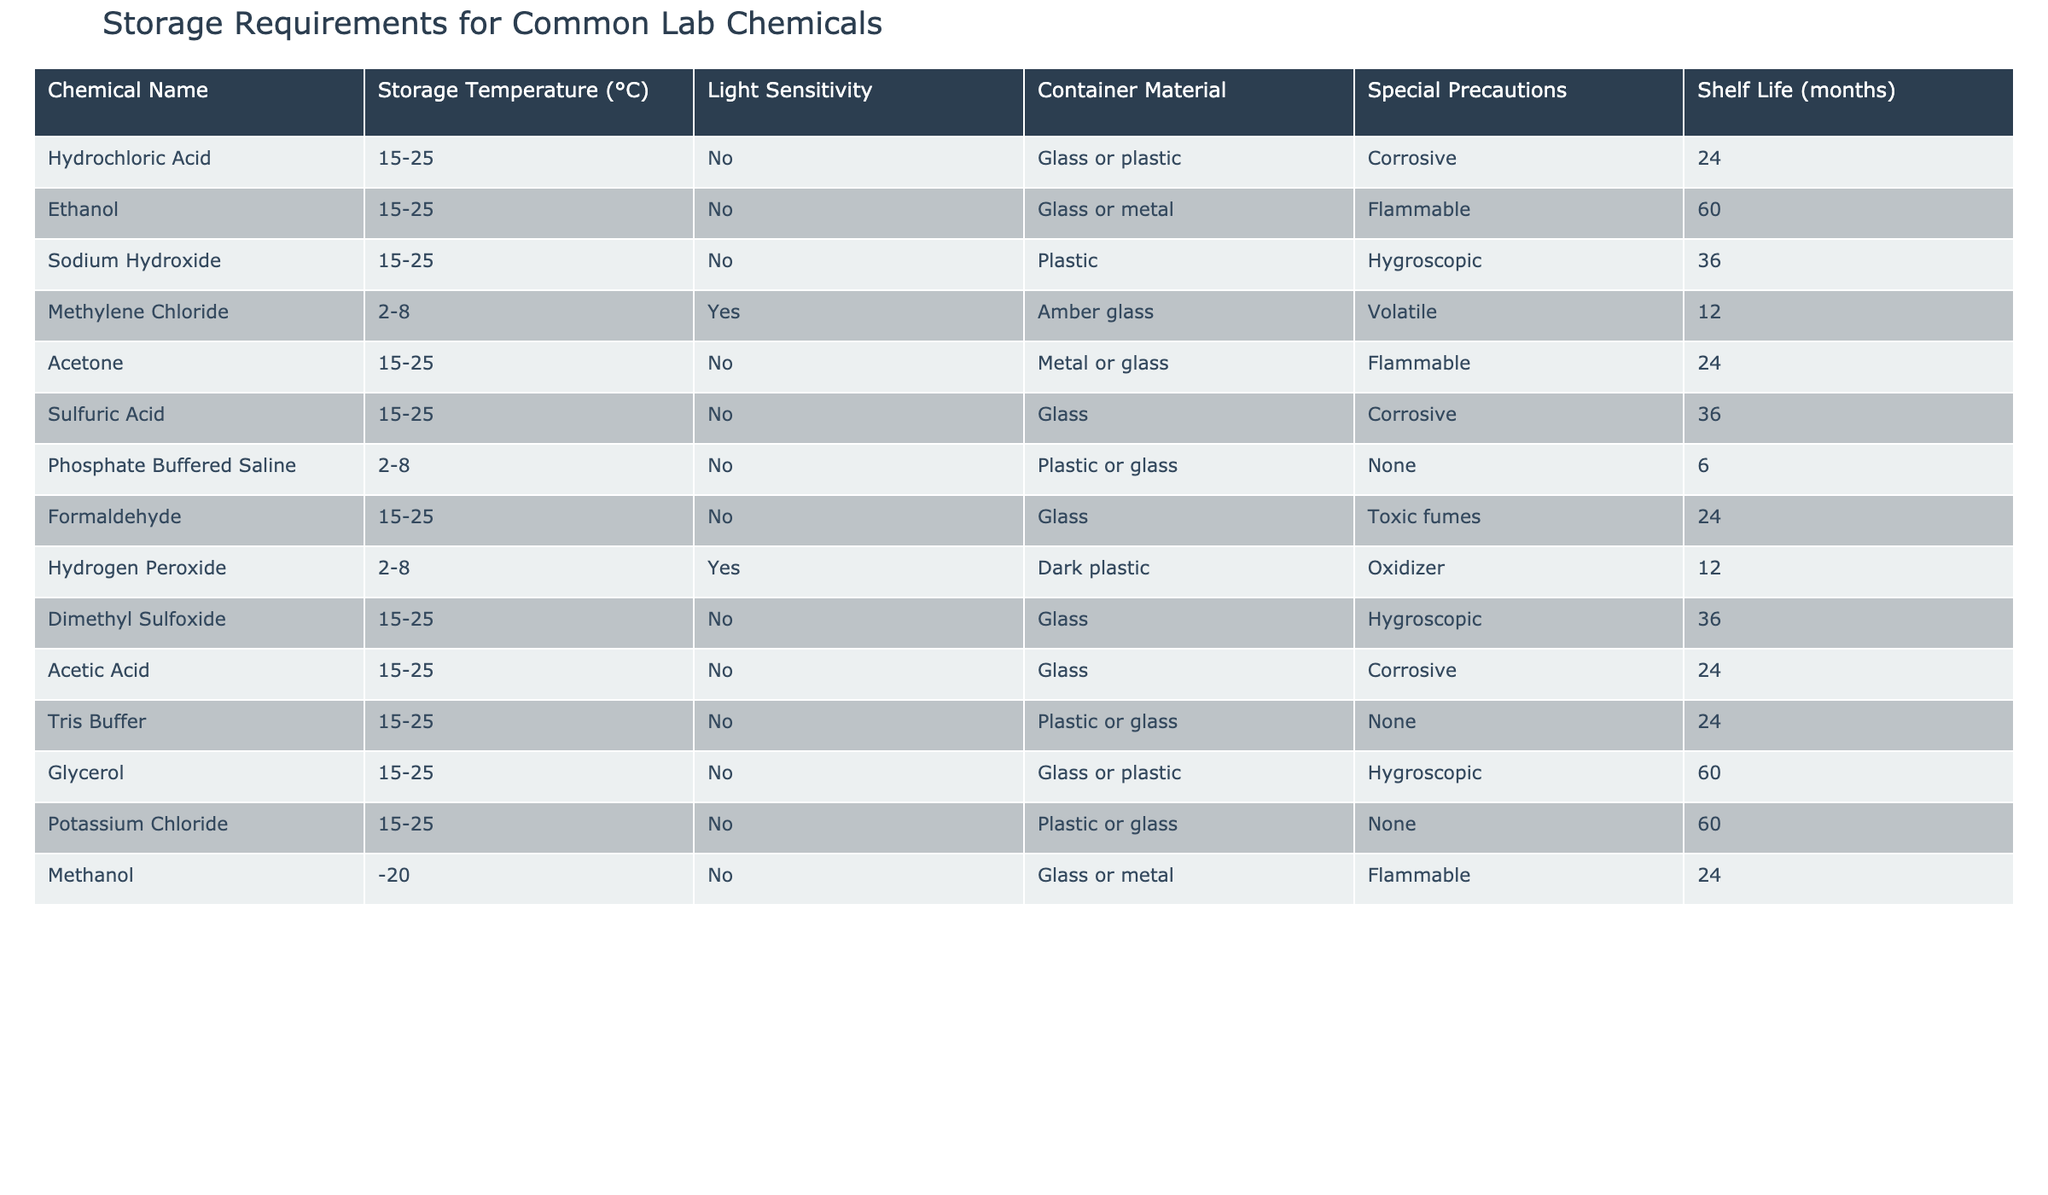What is the storage temperature range for Acetic Acid? The storage temperature range for Acetic Acid can be found in its row under the "Storage Temperature (°C)" column, which shows 15-25 °C.
Answer: 15-25 °C Which chemicals have a shelf life of 24 months? By scanning through the "Shelf Life (months)" column, the chemicals with a shelf life of 24 months are Hydrochloric Acid, Acetone, Formaldehyde, and Methanol.
Answer: Hydrochloric Acid, Acetone, Formaldehyde, Methanol Is Methylene Chloride sensitive to light? To answer this question, I refer to the "Light Sensitivity" column for Methylene Chloride, which indicates "Yes".
Answer: Yes What is the average shelf life of chemicals that are hygroscopic? The hygroscopic chemicals are Sodium Hydroxide, Dimethyl Sulfoxide, Glycerol, and Hydrogen Peroxide. Their shelf lives are 36, 36, 60, and 12 months, respectively. The average is calculated as (36 + 36 + 60 + 12) / 4 = 36.
Answer: 36 months Which container material is recommended for storing Sulfuric Acid? The "Container Material" column for Sulfuric Acid lists "Glass," making it the recommended storage material.
Answer: Glass How many chemicals are flammable? By checking the "Special Precautions" column for the relevant chemicals, I find that both Ethanol, Acetone, and Methanol are categorized as flammable. Thus, there are 3 flammable chemicals.
Answer: 3 What is the storage temperature range for the chemicals that are not sensitive to light? First, I filter out the chemicals that have "No" in the "Light Sensitivity" column. Those chemicals have a storage temperature range of 15-25 °C, except for Methylene Chloride, Phosphate Buffered Saline, and Hydrogen Peroxide, which are stored at 2-8 °C. Thus, two ranges exist: 15-25 °C and 2-8 °C.
Answer: 15-25 °C and 2-8 °C Do both Ethanol and Methanol require glass or metal containers? Looking at both their rows in the "Container Material" column shows that Ethanol requires either Glass or Metal, while Methanol requires Glass or Metal as well. Therefore, the answer is yes.
Answer: Yes 